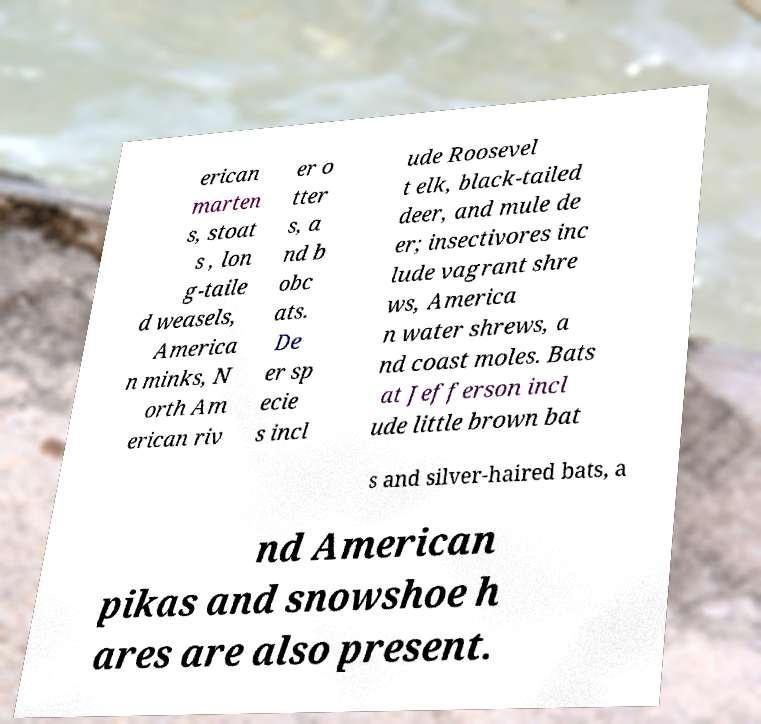What messages or text are displayed in this image? I need them in a readable, typed format. erican marten s, stoat s , lon g-taile d weasels, America n minks, N orth Am erican riv er o tter s, a nd b obc ats. De er sp ecie s incl ude Roosevel t elk, black-tailed deer, and mule de er; insectivores inc lude vagrant shre ws, America n water shrews, a nd coast moles. Bats at Jefferson incl ude little brown bat s and silver-haired bats, a nd American pikas and snowshoe h ares are also present. 